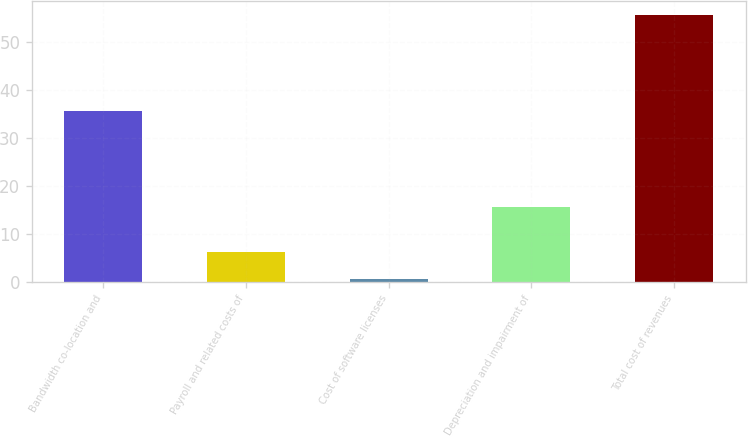Convert chart. <chart><loc_0><loc_0><loc_500><loc_500><bar_chart><fcel>Bandwidth co-location and<fcel>Payroll and related costs of<fcel>Cost of software licenses<fcel>Depreciation and impairment of<fcel>Total cost of revenues<nl><fcel>35.6<fcel>6.2<fcel>0.7<fcel>15.6<fcel>55.7<nl></chart> 